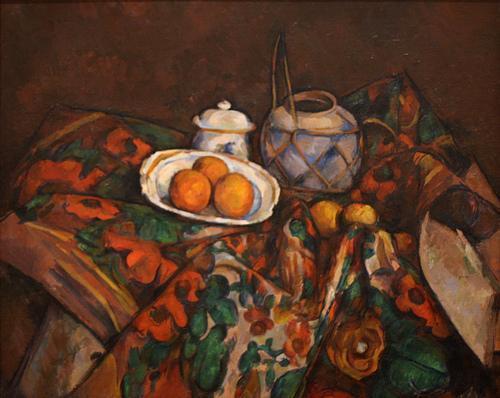How many oranges are there?
Give a very brief answer. 3. 